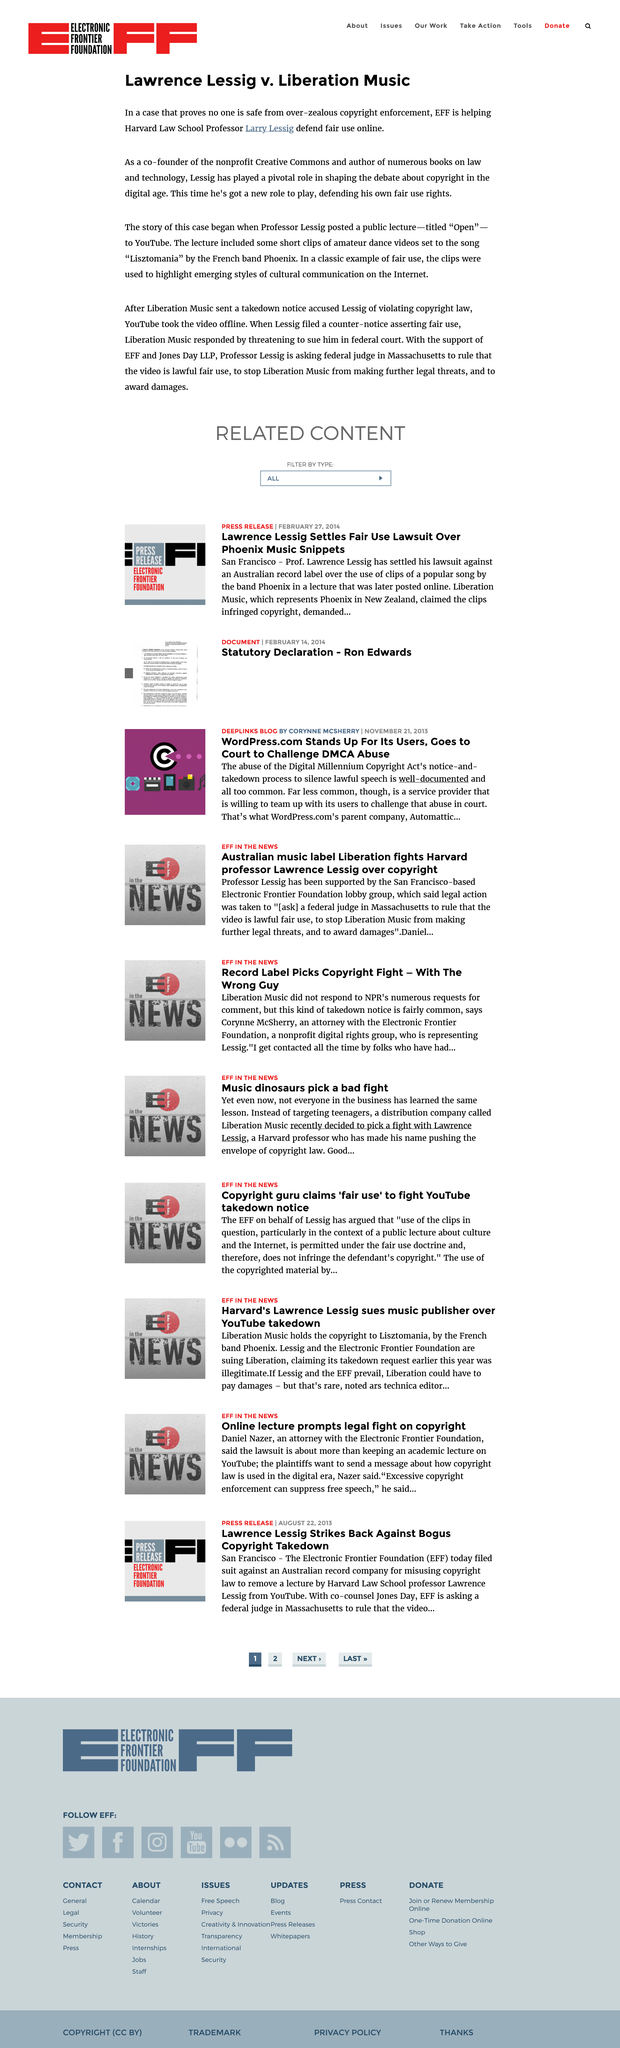Specify some key components in this picture. Harvard Law School is where Professor Lessig teaches. Lessig, a resident of Massachusetts, has filed a petition with a federal judge in Massachusetts, requesting a ruling on the fair use of the Liberation Music video in a case involving the copyright of song lyrics. The band Phoenix is described as being from France, according to the article "Lawrence Lessig v. Liberation Music. 